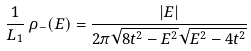Convert formula to latex. <formula><loc_0><loc_0><loc_500><loc_500>\frac { 1 } { L _ { 1 } } \, \rho _ { - } ( E ) = \frac { | E | } { 2 \pi \sqrt { 8 t ^ { 2 } - E ^ { 2 } } \sqrt { E ^ { 2 } - 4 t ^ { 2 } } }</formula> 